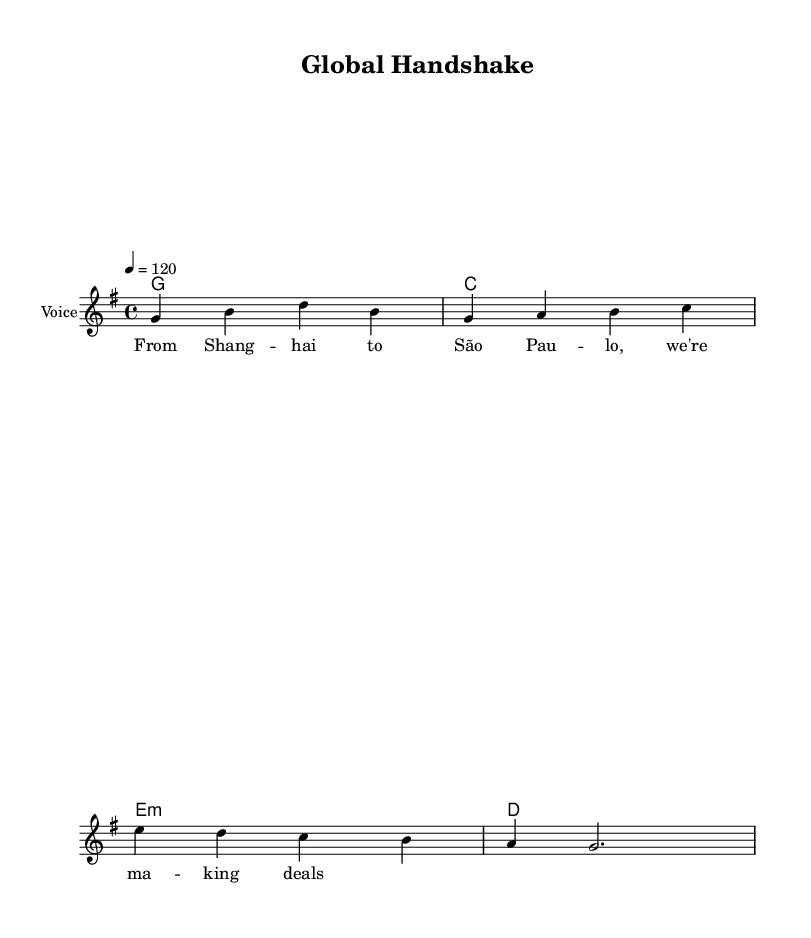What is the key signature of this music? The key signature is G major, which has one sharp (F#). This can be identified from the global section at the beginning of the music where it states "\key g \major".
Answer: G major What is the time signature of the piece? The time signature is 4/4, indicating that there are four beats in every measure, which is visible in the global section where it states "\time 4/4".
Answer: 4/4 What is the tempo marking for this music? The tempo marking is 120 beats per minute, specified in the global section with "\tempo 4 = 120". This indicates the speed at which the piece should be played.
Answer: 120 How many measures are in the melody? The melody consists of 4 measures, evident from the notated segments of the melody where each group of notes is separated by a measure line.
Answer: 4 What are the chord qualities used in the harmonies? The chord qualities in the harmonies are G major, C major, E minor, and D major. Each of these chords can be found in the chordmode section, where the specific letters indicate the chord type.
Answer: G, C, E minor, D What is the primary theme of the lyrics? The primary theme of the lyrics revolves around making business deals across international borders, as indicated in the line "From Shanghai to São Paulo, we're making deals". This reflects the concept the song is built around.
Answer: International trade How does the structure of the song reflect Country Rock characteristics? The structure includes a clear melody with an accompanying harmonic progression, paired with lyrics that depict a storytelling approach typical of Country Rock. The blend of narrative and music with a robust beat underlines its genre.
Answer: Narrative storytelling 